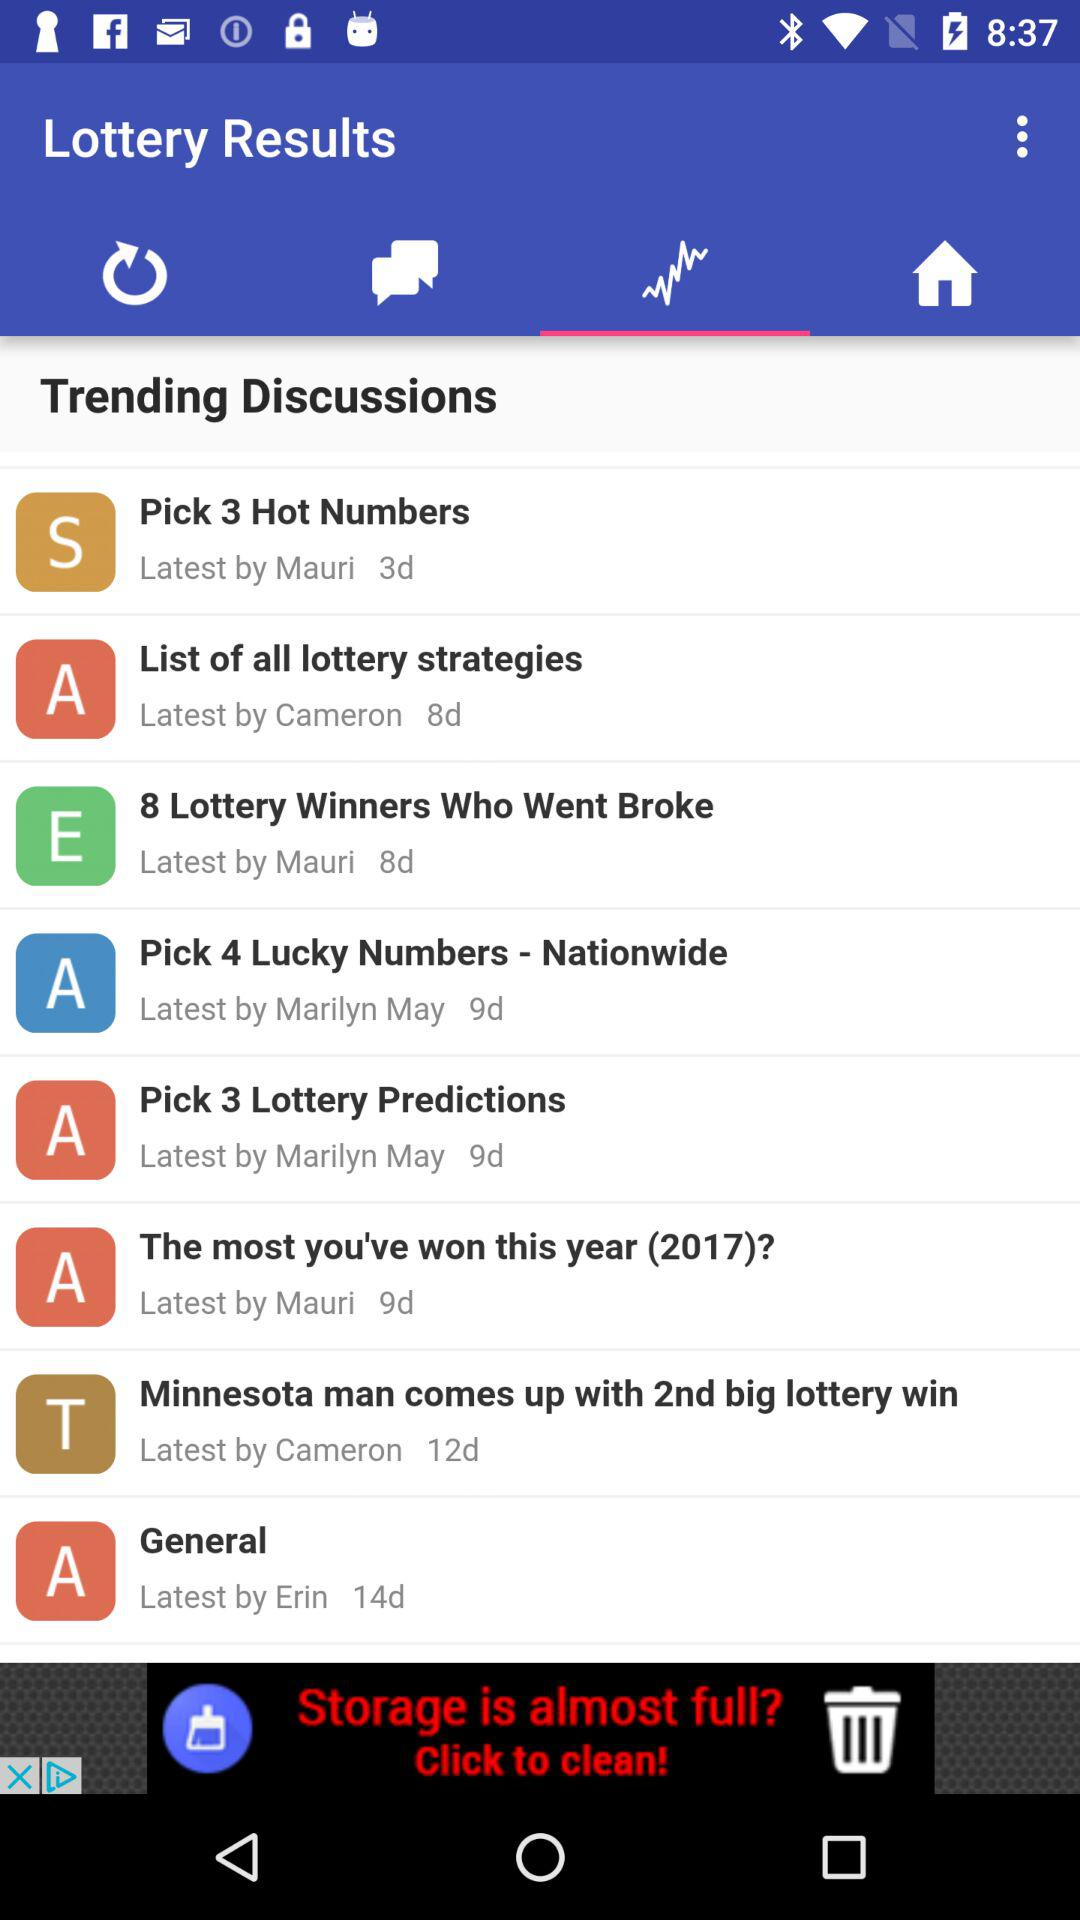What is the app name? The app name is "Lottery Results". 